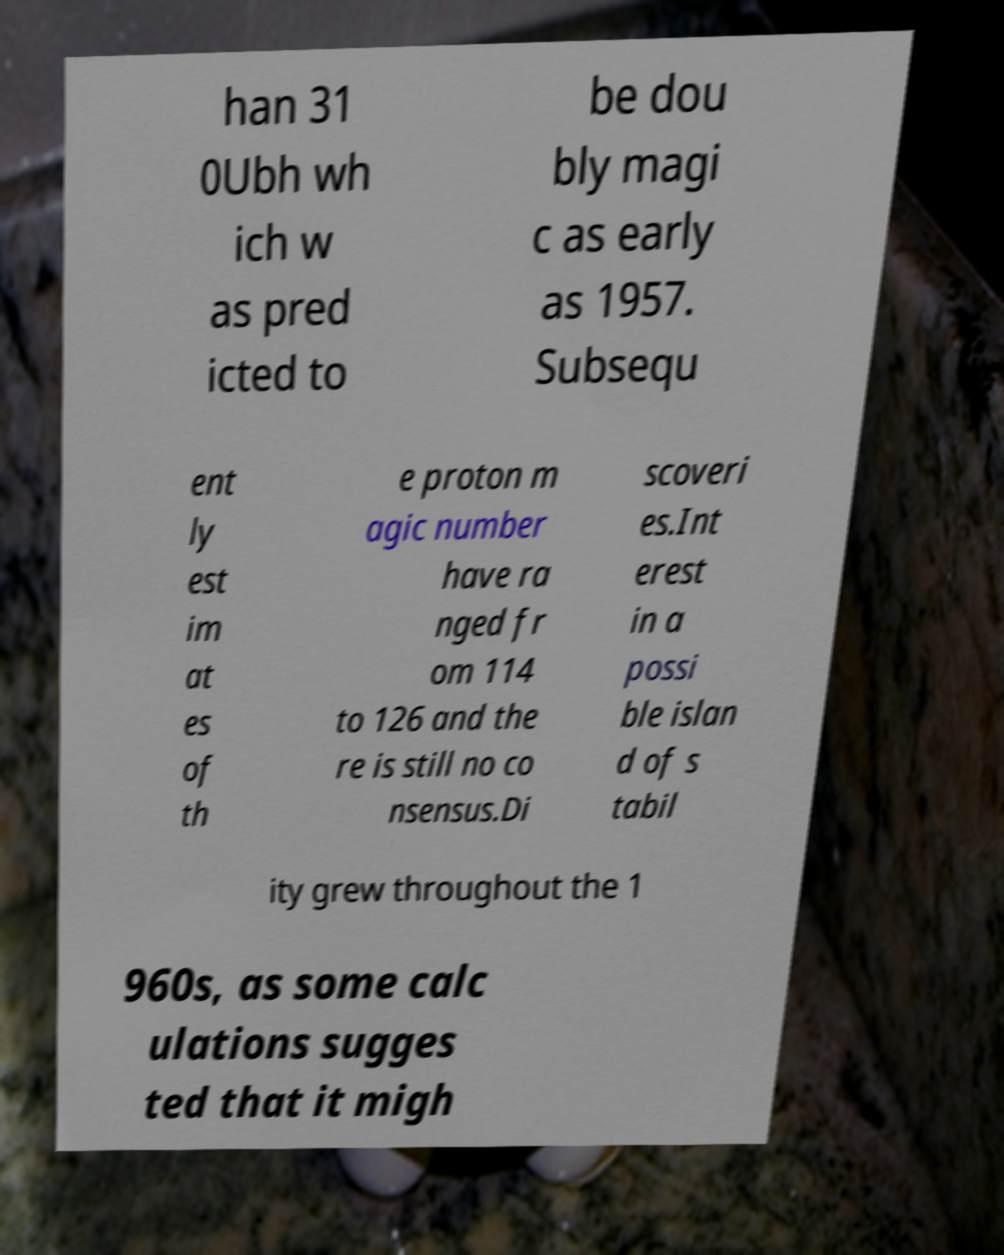Could you assist in decoding the text presented in this image and type it out clearly? han 31 0Ubh wh ich w as pred icted to be dou bly magi c as early as 1957. Subsequ ent ly est im at es of th e proton m agic number have ra nged fr om 114 to 126 and the re is still no co nsensus.Di scoveri es.Int erest in a possi ble islan d of s tabil ity grew throughout the 1 960s, as some calc ulations sugges ted that it migh 